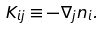Convert formula to latex. <formula><loc_0><loc_0><loc_500><loc_500>K _ { i j } \equiv - \nabla _ { j } n _ { i } .</formula> 